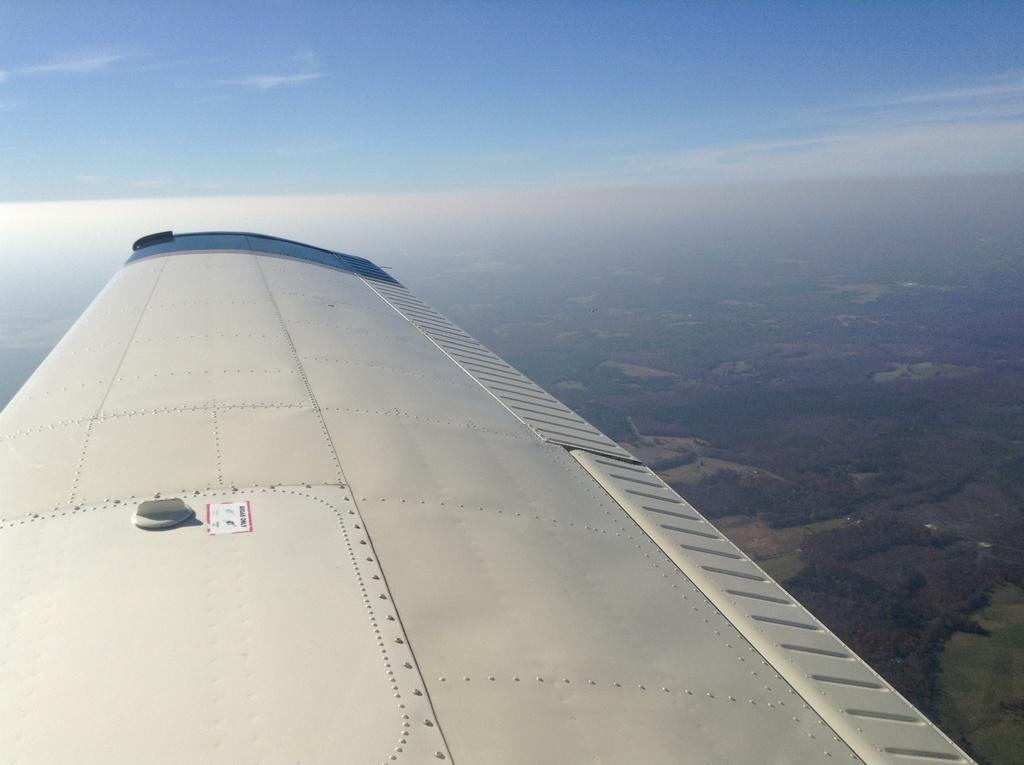Could you give a brief overview of what you see in this image? In this image we can see a wing of an airplane in the sky. In the background, we can see a group of trees. 